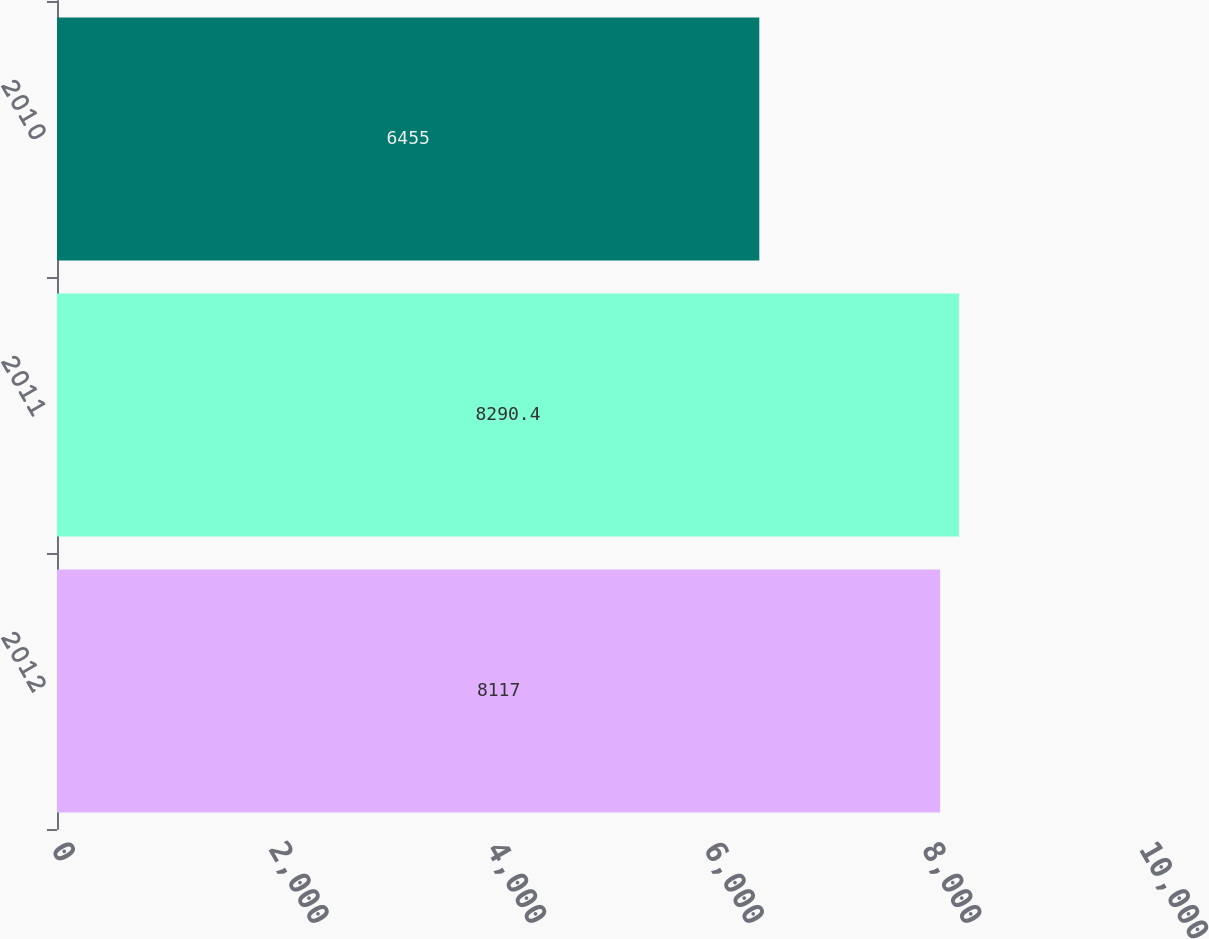Convert chart to OTSL. <chart><loc_0><loc_0><loc_500><loc_500><bar_chart><fcel>2012<fcel>2011<fcel>2010<nl><fcel>8117<fcel>8290.4<fcel>6455<nl></chart> 